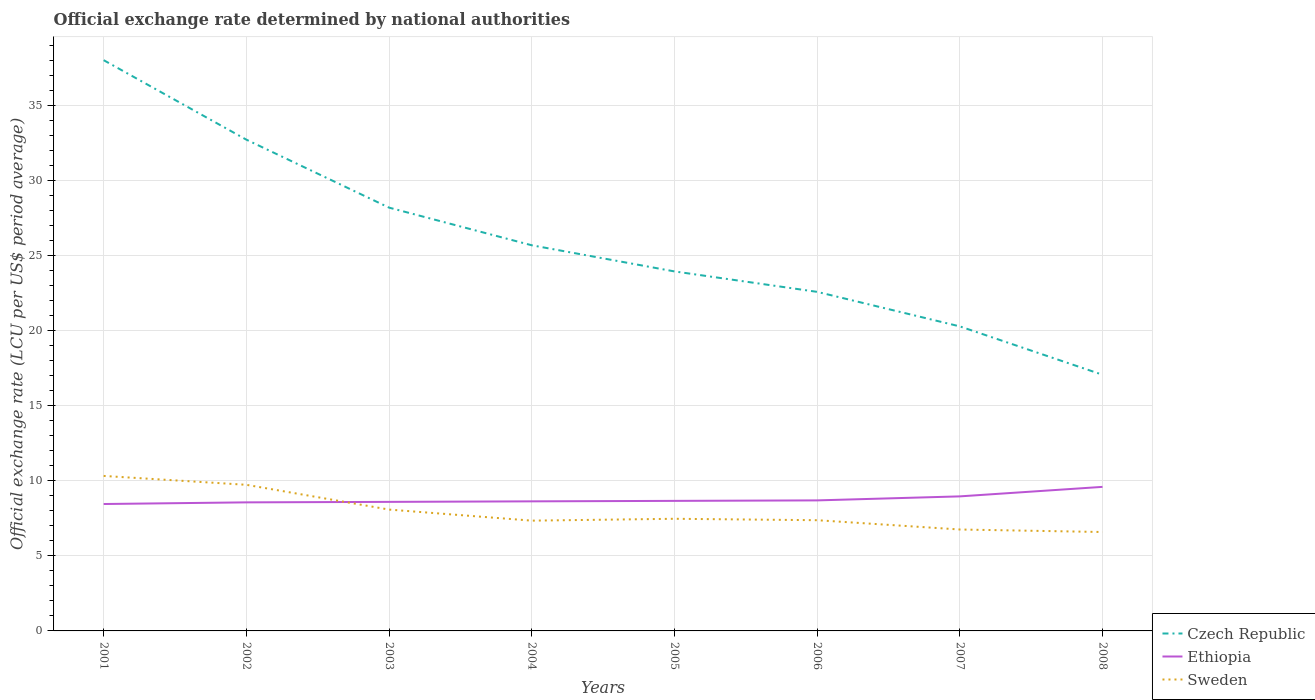Does the line corresponding to Czech Republic intersect with the line corresponding to Ethiopia?
Keep it short and to the point. No. Across all years, what is the maximum official exchange rate in Sweden?
Give a very brief answer. 6.59. What is the total official exchange rate in Sweden in the graph?
Keep it short and to the point. 0.17. What is the difference between the highest and the second highest official exchange rate in Sweden?
Offer a terse response. 3.74. What is the difference between the highest and the lowest official exchange rate in Ethiopia?
Offer a very short reply. 2. How many lines are there?
Provide a short and direct response. 3. How many years are there in the graph?
Offer a terse response. 8. Does the graph contain grids?
Ensure brevity in your answer.  Yes. What is the title of the graph?
Offer a terse response. Official exchange rate determined by national authorities. Does "Bahamas" appear as one of the legend labels in the graph?
Ensure brevity in your answer.  No. What is the label or title of the Y-axis?
Offer a very short reply. Official exchange rate (LCU per US$ period average). What is the Official exchange rate (LCU per US$ period average) of Czech Republic in 2001?
Ensure brevity in your answer.  38.04. What is the Official exchange rate (LCU per US$ period average) of Ethiopia in 2001?
Provide a short and direct response. 8.46. What is the Official exchange rate (LCU per US$ period average) in Sweden in 2001?
Offer a terse response. 10.33. What is the Official exchange rate (LCU per US$ period average) in Czech Republic in 2002?
Ensure brevity in your answer.  32.74. What is the Official exchange rate (LCU per US$ period average) of Ethiopia in 2002?
Offer a terse response. 8.57. What is the Official exchange rate (LCU per US$ period average) in Sweden in 2002?
Your answer should be very brief. 9.74. What is the Official exchange rate (LCU per US$ period average) in Czech Republic in 2003?
Your answer should be compact. 28.21. What is the Official exchange rate (LCU per US$ period average) of Ethiopia in 2003?
Make the answer very short. 8.6. What is the Official exchange rate (LCU per US$ period average) in Sweden in 2003?
Provide a short and direct response. 8.09. What is the Official exchange rate (LCU per US$ period average) in Czech Republic in 2004?
Keep it short and to the point. 25.7. What is the Official exchange rate (LCU per US$ period average) in Ethiopia in 2004?
Make the answer very short. 8.64. What is the Official exchange rate (LCU per US$ period average) in Sweden in 2004?
Provide a succinct answer. 7.35. What is the Official exchange rate (LCU per US$ period average) of Czech Republic in 2005?
Your answer should be very brief. 23.96. What is the Official exchange rate (LCU per US$ period average) of Ethiopia in 2005?
Ensure brevity in your answer.  8.67. What is the Official exchange rate (LCU per US$ period average) in Sweden in 2005?
Give a very brief answer. 7.47. What is the Official exchange rate (LCU per US$ period average) of Czech Republic in 2006?
Your response must be concise. 22.6. What is the Official exchange rate (LCU per US$ period average) in Ethiopia in 2006?
Provide a short and direct response. 8.7. What is the Official exchange rate (LCU per US$ period average) in Sweden in 2006?
Make the answer very short. 7.38. What is the Official exchange rate (LCU per US$ period average) of Czech Republic in 2007?
Your response must be concise. 20.29. What is the Official exchange rate (LCU per US$ period average) of Ethiopia in 2007?
Offer a very short reply. 8.97. What is the Official exchange rate (LCU per US$ period average) in Sweden in 2007?
Your response must be concise. 6.76. What is the Official exchange rate (LCU per US$ period average) in Czech Republic in 2008?
Your answer should be very brief. 17.07. What is the Official exchange rate (LCU per US$ period average) of Ethiopia in 2008?
Your response must be concise. 9.6. What is the Official exchange rate (LCU per US$ period average) in Sweden in 2008?
Offer a very short reply. 6.59. Across all years, what is the maximum Official exchange rate (LCU per US$ period average) in Czech Republic?
Provide a short and direct response. 38.04. Across all years, what is the maximum Official exchange rate (LCU per US$ period average) of Ethiopia?
Offer a very short reply. 9.6. Across all years, what is the maximum Official exchange rate (LCU per US$ period average) in Sweden?
Offer a very short reply. 10.33. Across all years, what is the minimum Official exchange rate (LCU per US$ period average) of Czech Republic?
Give a very brief answer. 17.07. Across all years, what is the minimum Official exchange rate (LCU per US$ period average) of Ethiopia?
Provide a short and direct response. 8.46. Across all years, what is the minimum Official exchange rate (LCU per US$ period average) of Sweden?
Keep it short and to the point. 6.59. What is the total Official exchange rate (LCU per US$ period average) in Czech Republic in the graph?
Your answer should be compact. 208.6. What is the total Official exchange rate (LCU per US$ period average) of Ethiopia in the graph?
Keep it short and to the point. 70.19. What is the total Official exchange rate (LCU per US$ period average) of Sweden in the graph?
Offer a very short reply. 63.7. What is the difference between the Official exchange rate (LCU per US$ period average) of Czech Republic in 2001 and that in 2002?
Your response must be concise. 5.3. What is the difference between the Official exchange rate (LCU per US$ period average) in Ethiopia in 2001 and that in 2002?
Keep it short and to the point. -0.11. What is the difference between the Official exchange rate (LCU per US$ period average) in Sweden in 2001 and that in 2002?
Offer a very short reply. 0.59. What is the difference between the Official exchange rate (LCU per US$ period average) in Czech Republic in 2001 and that in 2003?
Give a very brief answer. 9.83. What is the difference between the Official exchange rate (LCU per US$ period average) of Ethiopia in 2001 and that in 2003?
Give a very brief answer. -0.14. What is the difference between the Official exchange rate (LCU per US$ period average) in Sweden in 2001 and that in 2003?
Ensure brevity in your answer.  2.24. What is the difference between the Official exchange rate (LCU per US$ period average) of Czech Republic in 2001 and that in 2004?
Your answer should be compact. 12.34. What is the difference between the Official exchange rate (LCU per US$ period average) of Ethiopia in 2001 and that in 2004?
Offer a terse response. -0.18. What is the difference between the Official exchange rate (LCU per US$ period average) of Sweden in 2001 and that in 2004?
Offer a terse response. 2.98. What is the difference between the Official exchange rate (LCU per US$ period average) of Czech Republic in 2001 and that in 2005?
Your answer should be compact. 14.08. What is the difference between the Official exchange rate (LCU per US$ period average) of Ethiopia in 2001 and that in 2005?
Give a very brief answer. -0.21. What is the difference between the Official exchange rate (LCU per US$ period average) in Sweden in 2001 and that in 2005?
Offer a terse response. 2.86. What is the difference between the Official exchange rate (LCU per US$ period average) of Czech Republic in 2001 and that in 2006?
Offer a very short reply. 15.44. What is the difference between the Official exchange rate (LCU per US$ period average) in Ethiopia in 2001 and that in 2006?
Offer a terse response. -0.24. What is the difference between the Official exchange rate (LCU per US$ period average) of Sweden in 2001 and that in 2006?
Provide a short and direct response. 2.95. What is the difference between the Official exchange rate (LCU per US$ period average) of Czech Republic in 2001 and that in 2007?
Provide a short and direct response. 17.74. What is the difference between the Official exchange rate (LCU per US$ period average) of Ethiopia in 2001 and that in 2007?
Offer a terse response. -0.51. What is the difference between the Official exchange rate (LCU per US$ period average) of Sweden in 2001 and that in 2007?
Provide a succinct answer. 3.57. What is the difference between the Official exchange rate (LCU per US$ period average) of Czech Republic in 2001 and that in 2008?
Offer a very short reply. 20.96. What is the difference between the Official exchange rate (LCU per US$ period average) of Ethiopia in 2001 and that in 2008?
Offer a terse response. -1.14. What is the difference between the Official exchange rate (LCU per US$ period average) in Sweden in 2001 and that in 2008?
Provide a short and direct response. 3.74. What is the difference between the Official exchange rate (LCU per US$ period average) of Czech Republic in 2002 and that in 2003?
Your answer should be compact. 4.53. What is the difference between the Official exchange rate (LCU per US$ period average) of Ethiopia in 2002 and that in 2003?
Offer a terse response. -0.03. What is the difference between the Official exchange rate (LCU per US$ period average) in Sweden in 2002 and that in 2003?
Your answer should be very brief. 1.65. What is the difference between the Official exchange rate (LCU per US$ period average) of Czech Republic in 2002 and that in 2004?
Offer a very short reply. 7.04. What is the difference between the Official exchange rate (LCU per US$ period average) in Ethiopia in 2002 and that in 2004?
Offer a very short reply. -0.07. What is the difference between the Official exchange rate (LCU per US$ period average) of Sweden in 2002 and that in 2004?
Offer a very short reply. 2.39. What is the difference between the Official exchange rate (LCU per US$ period average) of Czech Republic in 2002 and that in 2005?
Your response must be concise. 8.78. What is the difference between the Official exchange rate (LCU per US$ period average) in Ethiopia in 2002 and that in 2005?
Your response must be concise. -0.1. What is the difference between the Official exchange rate (LCU per US$ period average) of Sweden in 2002 and that in 2005?
Keep it short and to the point. 2.26. What is the difference between the Official exchange rate (LCU per US$ period average) of Czech Republic in 2002 and that in 2006?
Give a very brief answer. 10.14. What is the difference between the Official exchange rate (LCU per US$ period average) in Ethiopia in 2002 and that in 2006?
Offer a terse response. -0.13. What is the difference between the Official exchange rate (LCU per US$ period average) in Sweden in 2002 and that in 2006?
Your answer should be very brief. 2.36. What is the difference between the Official exchange rate (LCU per US$ period average) of Czech Republic in 2002 and that in 2007?
Ensure brevity in your answer.  12.44. What is the difference between the Official exchange rate (LCU per US$ period average) of Ethiopia in 2002 and that in 2007?
Your answer should be very brief. -0.4. What is the difference between the Official exchange rate (LCU per US$ period average) in Sweden in 2002 and that in 2007?
Offer a terse response. 2.98. What is the difference between the Official exchange rate (LCU per US$ period average) of Czech Republic in 2002 and that in 2008?
Your response must be concise. 15.67. What is the difference between the Official exchange rate (LCU per US$ period average) in Ethiopia in 2002 and that in 2008?
Provide a short and direct response. -1.03. What is the difference between the Official exchange rate (LCU per US$ period average) in Sweden in 2002 and that in 2008?
Ensure brevity in your answer.  3.15. What is the difference between the Official exchange rate (LCU per US$ period average) of Czech Republic in 2003 and that in 2004?
Keep it short and to the point. 2.51. What is the difference between the Official exchange rate (LCU per US$ period average) in Ethiopia in 2003 and that in 2004?
Make the answer very short. -0.04. What is the difference between the Official exchange rate (LCU per US$ period average) of Sweden in 2003 and that in 2004?
Your answer should be very brief. 0.74. What is the difference between the Official exchange rate (LCU per US$ period average) of Czech Republic in 2003 and that in 2005?
Provide a short and direct response. 4.25. What is the difference between the Official exchange rate (LCU per US$ period average) in Ethiopia in 2003 and that in 2005?
Provide a succinct answer. -0.07. What is the difference between the Official exchange rate (LCU per US$ period average) of Sweden in 2003 and that in 2005?
Offer a very short reply. 0.61. What is the difference between the Official exchange rate (LCU per US$ period average) of Czech Republic in 2003 and that in 2006?
Provide a short and direct response. 5.61. What is the difference between the Official exchange rate (LCU per US$ period average) in Ethiopia in 2003 and that in 2006?
Your response must be concise. -0.1. What is the difference between the Official exchange rate (LCU per US$ period average) in Sweden in 2003 and that in 2006?
Your answer should be compact. 0.71. What is the difference between the Official exchange rate (LCU per US$ period average) in Czech Republic in 2003 and that in 2007?
Make the answer very short. 7.92. What is the difference between the Official exchange rate (LCU per US$ period average) in Ethiopia in 2003 and that in 2007?
Your answer should be compact. -0.37. What is the difference between the Official exchange rate (LCU per US$ period average) in Sweden in 2003 and that in 2007?
Provide a short and direct response. 1.33. What is the difference between the Official exchange rate (LCU per US$ period average) of Czech Republic in 2003 and that in 2008?
Offer a terse response. 11.14. What is the difference between the Official exchange rate (LCU per US$ period average) of Ethiopia in 2003 and that in 2008?
Keep it short and to the point. -1. What is the difference between the Official exchange rate (LCU per US$ period average) of Sweden in 2003 and that in 2008?
Offer a terse response. 1.5. What is the difference between the Official exchange rate (LCU per US$ period average) in Czech Republic in 2004 and that in 2005?
Provide a short and direct response. 1.74. What is the difference between the Official exchange rate (LCU per US$ period average) of Ethiopia in 2004 and that in 2005?
Offer a very short reply. -0.03. What is the difference between the Official exchange rate (LCU per US$ period average) in Sweden in 2004 and that in 2005?
Offer a very short reply. -0.12. What is the difference between the Official exchange rate (LCU per US$ period average) of Czech Republic in 2004 and that in 2006?
Ensure brevity in your answer.  3.1. What is the difference between the Official exchange rate (LCU per US$ period average) of Ethiopia in 2004 and that in 2006?
Provide a succinct answer. -0.06. What is the difference between the Official exchange rate (LCU per US$ period average) in Sweden in 2004 and that in 2006?
Your answer should be very brief. -0.03. What is the difference between the Official exchange rate (LCU per US$ period average) in Czech Republic in 2004 and that in 2007?
Offer a terse response. 5.41. What is the difference between the Official exchange rate (LCU per US$ period average) of Ethiopia in 2004 and that in 2007?
Your answer should be compact. -0.33. What is the difference between the Official exchange rate (LCU per US$ period average) in Sweden in 2004 and that in 2007?
Ensure brevity in your answer.  0.59. What is the difference between the Official exchange rate (LCU per US$ period average) in Czech Republic in 2004 and that in 2008?
Your answer should be very brief. 8.63. What is the difference between the Official exchange rate (LCU per US$ period average) in Ethiopia in 2004 and that in 2008?
Your answer should be very brief. -0.96. What is the difference between the Official exchange rate (LCU per US$ period average) in Sweden in 2004 and that in 2008?
Provide a succinct answer. 0.76. What is the difference between the Official exchange rate (LCU per US$ period average) in Czech Republic in 2005 and that in 2006?
Your answer should be very brief. 1.36. What is the difference between the Official exchange rate (LCU per US$ period average) in Ethiopia in 2005 and that in 2006?
Your answer should be compact. -0.03. What is the difference between the Official exchange rate (LCU per US$ period average) in Sweden in 2005 and that in 2006?
Your answer should be compact. 0.09. What is the difference between the Official exchange rate (LCU per US$ period average) of Czech Republic in 2005 and that in 2007?
Give a very brief answer. 3.66. What is the difference between the Official exchange rate (LCU per US$ period average) of Ethiopia in 2005 and that in 2007?
Offer a very short reply. -0.3. What is the difference between the Official exchange rate (LCU per US$ period average) of Sweden in 2005 and that in 2007?
Keep it short and to the point. 0.71. What is the difference between the Official exchange rate (LCU per US$ period average) of Czech Republic in 2005 and that in 2008?
Offer a terse response. 6.89. What is the difference between the Official exchange rate (LCU per US$ period average) in Ethiopia in 2005 and that in 2008?
Offer a very short reply. -0.93. What is the difference between the Official exchange rate (LCU per US$ period average) in Sweden in 2005 and that in 2008?
Offer a very short reply. 0.88. What is the difference between the Official exchange rate (LCU per US$ period average) of Czech Republic in 2006 and that in 2007?
Offer a terse response. 2.3. What is the difference between the Official exchange rate (LCU per US$ period average) of Ethiopia in 2006 and that in 2007?
Your response must be concise. -0.27. What is the difference between the Official exchange rate (LCU per US$ period average) in Sweden in 2006 and that in 2007?
Give a very brief answer. 0.62. What is the difference between the Official exchange rate (LCU per US$ period average) of Czech Republic in 2006 and that in 2008?
Provide a short and direct response. 5.52. What is the difference between the Official exchange rate (LCU per US$ period average) in Ethiopia in 2006 and that in 2008?
Offer a terse response. -0.9. What is the difference between the Official exchange rate (LCU per US$ period average) of Sweden in 2006 and that in 2008?
Ensure brevity in your answer.  0.79. What is the difference between the Official exchange rate (LCU per US$ period average) of Czech Republic in 2007 and that in 2008?
Provide a succinct answer. 3.22. What is the difference between the Official exchange rate (LCU per US$ period average) of Ethiopia in 2007 and that in 2008?
Your answer should be compact. -0.63. What is the difference between the Official exchange rate (LCU per US$ period average) in Sweden in 2007 and that in 2008?
Provide a short and direct response. 0.17. What is the difference between the Official exchange rate (LCU per US$ period average) of Czech Republic in 2001 and the Official exchange rate (LCU per US$ period average) of Ethiopia in 2002?
Offer a very short reply. 29.47. What is the difference between the Official exchange rate (LCU per US$ period average) of Czech Republic in 2001 and the Official exchange rate (LCU per US$ period average) of Sweden in 2002?
Provide a succinct answer. 28.3. What is the difference between the Official exchange rate (LCU per US$ period average) of Ethiopia in 2001 and the Official exchange rate (LCU per US$ period average) of Sweden in 2002?
Keep it short and to the point. -1.28. What is the difference between the Official exchange rate (LCU per US$ period average) of Czech Republic in 2001 and the Official exchange rate (LCU per US$ period average) of Ethiopia in 2003?
Offer a terse response. 29.44. What is the difference between the Official exchange rate (LCU per US$ period average) of Czech Republic in 2001 and the Official exchange rate (LCU per US$ period average) of Sweden in 2003?
Give a very brief answer. 29.95. What is the difference between the Official exchange rate (LCU per US$ period average) of Ethiopia in 2001 and the Official exchange rate (LCU per US$ period average) of Sweden in 2003?
Your answer should be very brief. 0.37. What is the difference between the Official exchange rate (LCU per US$ period average) of Czech Republic in 2001 and the Official exchange rate (LCU per US$ period average) of Ethiopia in 2004?
Give a very brief answer. 29.4. What is the difference between the Official exchange rate (LCU per US$ period average) of Czech Republic in 2001 and the Official exchange rate (LCU per US$ period average) of Sweden in 2004?
Make the answer very short. 30.69. What is the difference between the Official exchange rate (LCU per US$ period average) in Ethiopia in 2001 and the Official exchange rate (LCU per US$ period average) in Sweden in 2004?
Provide a succinct answer. 1.11. What is the difference between the Official exchange rate (LCU per US$ period average) in Czech Republic in 2001 and the Official exchange rate (LCU per US$ period average) in Ethiopia in 2005?
Give a very brief answer. 29.37. What is the difference between the Official exchange rate (LCU per US$ period average) in Czech Republic in 2001 and the Official exchange rate (LCU per US$ period average) in Sweden in 2005?
Make the answer very short. 30.56. What is the difference between the Official exchange rate (LCU per US$ period average) of Ethiopia in 2001 and the Official exchange rate (LCU per US$ period average) of Sweden in 2005?
Your answer should be compact. 0.98. What is the difference between the Official exchange rate (LCU per US$ period average) of Czech Republic in 2001 and the Official exchange rate (LCU per US$ period average) of Ethiopia in 2006?
Provide a succinct answer. 29.34. What is the difference between the Official exchange rate (LCU per US$ period average) of Czech Republic in 2001 and the Official exchange rate (LCU per US$ period average) of Sweden in 2006?
Make the answer very short. 30.66. What is the difference between the Official exchange rate (LCU per US$ period average) of Ethiopia in 2001 and the Official exchange rate (LCU per US$ period average) of Sweden in 2006?
Ensure brevity in your answer.  1.08. What is the difference between the Official exchange rate (LCU per US$ period average) of Czech Republic in 2001 and the Official exchange rate (LCU per US$ period average) of Ethiopia in 2007?
Provide a succinct answer. 29.07. What is the difference between the Official exchange rate (LCU per US$ period average) of Czech Republic in 2001 and the Official exchange rate (LCU per US$ period average) of Sweden in 2007?
Give a very brief answer. 31.28. What is the difference between the Official exchange rate (LCU per US$ period average) in Ethiopia in 2001 and the Official exchange rate (LCU per US$ period average) in Sweden in 2007?
Offer a very short reply. 1.7. What is the difference between the Official exchange rate (LCU per US$ period average) in Czech Republic in 2001 and the Official exchange rate (LCU per US$ period average) in Ethiopia in 2008?
Give a very brief answer. 28.44. What is the difference between the Official exchange rate (LCU per US$ period average) in Czech Republic in 2001 and the Official exchange rate (LCU per US$ period average) in Sweden in 2008?
Keep it short and to the point. 31.44. What is the difference between the Official exchange rate (LCU per US$ period average) in Ethiopia in 2001 and the Official exchange rate (LCU per US$ period average) in Sweden in 2008?
Your answer should be compact. 1.87. What is the difference between the Official exchange rate (LCU per US$ period average) of Czech Republic in 2002 and the Official exchange rate (LCU per US$ period average) of Ethiopia in 2003?
Provide a succinct answer. 24.14. What is the difference between the Official exchange rate (LCU per US$ period average) in Czech Republic in 2002 and the Official exchange rate (LCU per US$ period average) in Sweden in 2003?
Offer a terse response. 24.65. What is the difference between the Official exchange rate (LCU per US$ period average) in Ethiopia in 2002 and the Official exchange rate (LCU per US$ period average) in Sweden in 2003?
Your answer should be compact. 0.48. What is the difference between the Official exchange rate (LCU per US$ period average) of Czech Republic in 2002 and the Official exchange rate (LCU per US$ period average) of Ethiopia in 2004?
Keep it short and to the point. 24.1. What is the difference between the Official exchange rate (LCU per US$ period average) of Czech Republic in 2002 and the Official exchange rate (LCU per US$ period average) of Sweden in 2004?
Your answer should be compact. 25.39. What is the difference between the Official exchange rate (LCU per US$ period average) of Ethiopia in 2002 and the Official exchange rate (LCU per US$ period average) of Sweden in 2004?
Give a very brief answer. 1.22. What is the difference between the Official exchange rate (LCU per US$ period average) of Czech Republic in 2002 and the Official exchange rate (LCU per US$ period average) of Ethiopia in 2005?
Offer a very short reply. 24.07. What is the difference between the Official exchange rate (LCU per US$ period average) in Czech Republic in 2002 and the Official exchange rate (LCU per US$ period average) in Sweden in 2005?
Offer a terse response. 25.27. What is the difference between the Official exchange rate (LCU per US$ period average) in Ethiopia in 2002 and the Official exchange rate (LCU per US$ period average) in Sweden in 2005?
Make the answer very short. 1.09. What is the difference between the Official exchange rate (LCU per US$ period average) of Czech Republic in 2002 and the Official exchange rate (LCU per US$ period average) of Ethiopia in 2006?
Keep it short and to the point. 24.04. What is the difference between the Official exchange rate (LCU per US$ period average) of Czech Republic in 2002 and the Official exchange rate (LCU per US$ period average) of Sweden in 2006?
Offer a very short reply. 25.36. What is the difference between the Official exchange rate (LCU per US$ period average) in Ethiopia in 2002 and the Official exchange rate (LCU per US$ period average) in Sweden in 2006?
Offer a terse response. 1.19. What is the difference between the Official exchange rate (LCU per US$ period average) in Czech Republic in 2002 and the Official exchange rate (LCU per US$ period average) in Ethiopia in 2007?
Make the answer very short. 23.77. What is the difference between the Official exchange rate (LCU per US$ period average) of Czech Republic in 2002 and the Official exchange rate (LCU per US$ period average) of Sweden in 2007?
Your answer should be compact. 25.98. What is the difference between the Official exchange rate (LCU per US$ period average) in Ethiopia in 2002 and the Official exchange rate (LCU per US$ period average) in Sweden in 2007?
Your response must be concise. 1.81. What is the difference between the Official exchange rate (LCU per US$ period average) in Czech Republic in 2002 and the Official exchange rate (LCU per US$ period average) in Ethiopia in 2008?
Provide a succinct answer. 23.14. What is the difference between the Official exchange rate (LCU per US$ period average) of Czech Republic in 2002 and the Official exchange rate (LCU per US$ period average) of Sweden in 2008?
Offer a terse response. 26.15. What is the difference between the Official exchange rate (LCU per US$ period average) of Ethiopia in 2002 and the Official exchange rate (LCU per US$ period average) of Sweden in 2008?
Your answer should be compact. 1.98. What is the difference between the Official exchange rate (LCU per US$ period average) of Czech Republic in 2003 and the Official exchange rate (LCU per US$ period average) of Ethiopia in 2004?
Make the answer very short. 19.57. What is the difference between the Official exchange rate (LCU per US$ period average) in Czech Republic in 2003 and the Official exchange rate (LCU per US$ period average) in Sweden in 2004?
Keep it short and to the point. 20.86. What is the difference between the Official exchange rate (LCU per US$ period average) of Ethiopia in 2003 and the Official exchange rate (LCU per US$ period average) of Sweden in 2004?
Offer a very short reply. 1.25. What is the difference between the Official exchange rate (LCU per US$ period average) in Czech Republic in 2003 and the Official exchange rate (LCU per US$ period average) in Ethiopia in 2005?
Your response must be concise. 19.54. What is the difference between the Official exchange rate (LCU per US$ period average) in Czech Republic in 2003 and the Official exchange rate (LCU per US$ period average) in Sweden in 2005?
Provide a succinct answer. 20.74. What is the difference between the Official exchange rate (LCU per US$ period average) of Ethiopia in 2003 and the Official exchange rate (LCU per US$ period average) of Sweden in 2005?
Offer a terse response. 1.13. What is the difference between the Official exchange rate (LCU per US$ period average) in Czech Republic in 2003 and the Official exchange rate (LCU per US$ period average) in Ethiopia in 2006?
Give a very brief answer. 19.51. What is the difference between the Official exchange rate (LCU per US$ period average) of Czech Republic in 2003 and the Official exchange rate (LCU per US$ period average) of Sweden in 2006?
Offer a very short reply. 20.83. What is the difference between the Official exchange rate (LCU per US$ period average) of Ethiopia in 2003 and the Official exchange rate (LCU per US$ period average) of Sweden in 2006?
Keep it short and to the point. 1.22. What is the difference between the Official exchange rate (LCU per US$ period average) of Czech Republic in 2003 and the Official exchange rate (LCU per US$ period average) of Ethiopia in 2007?
Provide a succinct answer. 19.24. What is the difference between the Official exchange rate (LCU per US$ period average) of Czech Republic in 2003 and the Official exchange rate (LCU per US$ period average) of Sweden in 2007?
Provide a short and direct response. 21.45. What is the difference between the Official exchange rate (LCU per US$ period average) in Ethiopia in 2003 and the Official exchange rate (LCU per US$ period average) in Sweden in 2007?
Keep it short and to the point. 1.84. What is the difference between the Official exchange rate (LCU per US$ period average) in Czech Republic in 2003 and the Official exchange rate (LCU per US$ period average) in Ethiopia in 2008?
Your response must be concise. 18.61. What is the difference between the Official exchange rate (LCU per US$ period average) in Czech Republic in 2003 and the Official exchange rate (LCU per US$ period average) in Sweden in 2008?
Keep it short and to the point. 21.62. What is the difference between the Official exchange rate (LCU per US$ period average) of Ethiopia in 2003 and the Official exchange rate (LCU per US$ period average) of Sweden in 2008?
Your response must be concise. 2.01. What is the difference between the Official exchange rate (LCU per US$ period average) of Czech Republic in 2004 and the Official exchange rate (LCU per US$ period average) of Ethiopia in 2005?
Your answer should be compact. 17.03. What is the difference between the Official exchange rate (LCU per US$ period average) of Czech Republic in 2004 and the Official exchange rate (LCU per US$ period average) of Sweden in 2005?
Make the answer very short. 18.23. What is the difference between the Official exchange rate (LCU per US$ period average) of Ethiopia in 2004 and the Official exchange rate (LCU per US$ period average) of Sweden in 2005?
Your answer should be very brief. 1.16. What is the difference between the Official exchange rate (LCU per US$ period average) in Czech Republic in 2004 and the Official exchange rate (LCU per US$ period average) in Ethiopia in 2006?
Your response must be concise. 17. What is the difference between the Official exchange rate (LCU per US$ period average) in Czech Republic in 2004 and the Official exchange rate (LCU per US$ period average) in Sweden in 2006?
Your answer should be very brief. 18.32. What is the difference between the Official exchange rate (LCU per US$ period average) of Ethiopia in 2004 and the Official exchange rate (LCU per US$ period average) of Sweden in 2006?
Offer a terse response. 1.26. What is the difference between the Official exchange rate (LCU per US$ period average) of Czech Republic in 2004 and the Official exchange rate (LCU per US$ period average) of Ethiopia in 2007?
Your response must be concise. 16.73. What is the difference between the Official exchange rate (LCU per US$ period average) of Czech Republic in 2004 and the Official exchange rate (LCU per US$ period average) of Sweden in 2007?
Offer a very short reply. 18.94. What is the difference between the Official exchange rate (LCU per US$ period average) of Ethiopia in 2004 and the Official exchange rate (LCU per US$ period average) of Sweden in 2007?
Your response must be concise. 1.88. What is the difference between the Official exchange rate (LCU per US$ period average) of Czech Republic in 2004 and the Official exchange rate (LCU per US$ period average) of Ethiopia in 2008?
Your answer should be very brief. 16.1. What is the difference between the Official exchange rate (LCU per US$ period average) in Czech Republic in 2004 and the Official exchange rate (LCU per US$ period average) in Sweden in 2008?
Your response must be concise. 19.11. What is the difference between the Official exchange rate (LCU per US$ period average) in Ethiopia in 2004 and the Official exchange rate (LCU per US$ period average) in Sweden in 2008?
Keep it short and to the point. 2.04. What is the difference between the Official exchange rate (LCU per US$ period average) of Czech Republic in 2005 and the Official exchange rate (LCU per US$ period average) of Ethiopia in 2006?
Make the answer very short. 15.26. What is the difference between the Official exchange rate (LCU per US$ period average) in Czech Republic in 2005 and the Official exchange rate (LCU per US$ period average) in Sweden in 2006?
Your response must be concise. 16.58. What is the difference between the Official exchange rate (LCU per US$ period average) of Ethiopia in 2005 and the Official exchange rate (LCU per US$ period average) of Sweden in 2006?
Provide a short and direct response. 1.29. What is the difference between the Official exchange rate (LCU per US$ period average) of Czech Republic in 2005 and the Official exchange rate (LCU per US$ period average) of Ethiopia in 2007?
Your response must be concise. 14.99. What is the difference between the Official exchange rate (LCU per US$ period average) of Czech Republic in 2005 and the Official exchange rate (LCU per US$ period average) of Sweden in 2007?
Offer a very short reply. 17.2. What is the difference between the Official exchange rate (LCU per US$ period average) in Ethiopia in 2005 and the Official exchange rate (LCU per US$ period average) in Sweden in 2007?
Your response must be concise. 1.91. What is the difference between the Official exchange rate (LCU per US$ period average) of Czech Republic in 2005 and the Official exchange rate (LCU per US$ period average) of Ethiopia in 2008?
Give a very brief answer. 14.36. What is the difference between the Official exchange rate (LCU per US$ period average) in Czech Republic in 2005 and the Official exchange rate (LCU per US$ period average) in Sweden in 2008?
Your response must be concise. 17.37. What is the difference between the Official exchange rate (LCU per US$ period average) in Ethiopia in 2005 and the Official exchange rate (LCU per US$ period average) in Sweden in 2008?
Ensure brevity in your answer.  2.08. What is the difference between the Official exchange rate (LCU per US$ period average) in Czech Republic in 2006 and the Official exchange rate (LCU per US$ period average) in Ethiopia in 2007?
Provide a short and direct response. 13.63. What is the difference between the Official exchange rate (LCU per US$ period average) in Czech Republic in 2006 and the Official exchange rate (LCU per US$ period average) in Sweden in 2007?
Give a very brief answer. 15.84. What is the difference between the Official exchange rate (LCU per US$ period average) in Ethiopia in 2006 and the Official exchange rate (LCU per US$ period average) in Sweden in 2007?
Keep it short and to the point. 1.94. What is the difference between the Official exchange rate (LCU per US$ period average) in Czech Republic in 2006 and the Official exchange rate (LCU per US$ period average) in Ethiopia in 2008?
Offer a very short reply. 13. What is the difference between the Official exchange rate (LCU per US$ period average) in Czech Republic in 2006 and the Official exchange rate (LCU per US$ period average) in Sweden in 2008?
Your answer should be very brief. 16. What is the difference between the Official exchange rate (LCU per US$ period average) in Ethiopia in 2006 and the Official exchange rate (LCU per US$ period average) in Sweden in 2008?
Offer a terse response. 2.11. What is the difference between the Official exchange rate (LCU per US$ period average) of Czech Republic in 2007 and the Official exchange rate (LCU per US$ period average) of Ethiopia in 2008?
Ensure brevity in your answer.  10.69. What is the difference between the Official exchange rate (LCU per US$ period average) in Czech Republic in 2007 and the Official exchange rate (LCU per US$ period average) in Sweden in 2008?
Offer a terse response. 13.7. What is the difference between the Official exchange rate (LCU per US$ period average) in Ethiopia in 2007 and the Official exchange rate (LCU per US$ period average) in Sweden in 2008?
Provide a succinct answer. 2.37. What is the average Official exchange rate (LCU per US$ period average) in Czech Republic per year?
Your response must be concise. 26.08. What is the average Official exchange rate (LCU per US$ period average) of Ethiopia per year?
Provide a short and direct response. 8.77. What is the average Official exchange rate (LCU per US$ period average) of Sweden per year?
Offer a terse response. 7.96. In the year 2001, what is the difference between the Official exchange rate (LCU per US$ period average) of Czech Republic and Official exchange rate (LCU per US$ period average) of Ethiopia?
Offer a very short reply. 29.58. In the year 2001, what is the difference between the Official exchange rate (LCU per US$ period average) of Czech Republic and Official exchange rate (LCU per US$ period average) of Sweden?
Offer a terse response. 27.71. In the year 2001, what is the difference between the Official exchange rate (LCU per US$ period average) in Ethiopia and Official exchange rate (LCU per US$ period average) in Sweden?
Offer a very short reply. -1.87. In the year 2002, what is the difference between the Official exchange rate (LCU per US$ period average) of Czech Republic and Official exchange rate (LCU per US$ period average) of Ethiopia?
Give a very brief answer. 24.17. In the year 2002, what is the difference between the Official exchange rate (LCU per US$ period average) of Czech Republic and Official exchange rate (LCU per US$ period average) of Sweden?
Ensure brevity in your answer.  23. In the year 2002, what is the difference between the Official exchange rate (LCU per US$ period average) in Ethiopia and Official exchange rate (LCU per US$ period average) in Sweden?
Give a very brief answer. -1.17. In the year 2003, what is the difference between the Official exchange rate (LCU per US$ period average) of Czech Republic and Official exchange rate (LCU per US$ period average) of Ethiopia?
Keep it short and to the point. 19.61. In the year 2003, what is the difference between the Official exchange rate (LCU per US$ period average) of Czech Republic and Official exchange rate (LCU per US$ period average) of Sweden?
Your response must be concise. 20.12. In the year 2003, what is the difference between the Official exchange rate (LCU per US$ period average) in Ethiopia and Official exchange rate (LCU per US$ period average) in Sweden?
Give a very brief answer. 0.51. In the year 2004, what is the difference between the Official exchange rate (LCU per US$ period average) in Czech Republic and Official exchange rate (LCU per US$ period average) in Ethiopia?
Your answer should be very brief. 17.06. In the year 2004, what is the difference between the Official exchange rate (LCU per US$ period average) of Czech Republic and Official exchange rate (LCU per US$ period average) of Sweden?
Ensure brevity in your answer.  18.35. In the year 2004, what is the difference between the Official exchange rate (LCU per US$ period average) in Ethiopia and Official exchange rate (LCU per US$ period average) in Sweden?
Give a very brief answer. 1.29. In the year 2005, what is the difference between the Official exchange rate (LCU per US$ period average) in Czech Republic and Official exchange rate (LCU per US$ period average) in Ethiopia?
Your answer should be very brief. 15.29. In the year 2005, what is the difference between the Official exchange rate (LCU per US$ period average) in Czech Republic and Official exchange rate (LCU per US$ period average) in Sweden?
Your response must be concise. 16.48. In the year 2005, what is the difference between the Official exchange rate (LCU per US$ period average) of Ethiopia and Official exchange rate (LCU per US$ period average) of Sweden?
Your answer should be very brief. 1.19. In the year 2006, what is the difference between the Official exchange rate (LCU per US$ period average) in Czech Republic and Official exchange rate (LCU per US$ period average) in Ethiopia?
Offer a terse response. 13.9. In the year 2006, what is the difference between the Official exchange rate (LCU per US$ period average) in Czech Republic and Official exchange rate (LCU per US$ period average) in Sweden?
Provide a succinct answer. 15.22. In the year 2006, what is the difference between the Official exchange rate (LCU per US$ period average) in Ethiopia and Official exchange rate (LCU per US$ period average) in Sweden?
Make the answer very short. 1.32. In the year 2007, what is the difference between the Official exchange rate (LCU per US$ period average) in Czech Republic and Official exchange rate (LCU per US$ period average) in Ethiopia?
Your answer should be compact. 11.33. In the year 2007, what is the difference between the Official exchange rate (LCU per US$ period average) in Czech Republic and Official exchange rate (LCU per US$ period average) in Sweden?
Offer a terse response. 13.53. In the year 2007, what is the difference between the Official exchange rate (LCU per US$ period average) of Ethiopia and Official exchange rate (LCU per US$ period average) of Sweden?
Provide a succinct answer. 2.21. In the year 2008, what is the difference between the Official exchange rate (LCU per US$ period average) in Czech Republic and Official exchange rate (LCU per US$ period average) in Ethiopia?
Offer a very short reply. 7.47. In the year 2008, what is the difference between the Official exchange rate (LCU per US$ period average) of Czech Republic and Official exchange rate (LCU per US$ period average) of Sweden?
Offer a terse response. 10.48. In the year 2008, what is the difference between the Official exchange rate (LCU per US$ period average) of Ethiopia and Official exchange rate (LCU per US$ period average) of Sweden?
Give a very brief answer. 3.01. What is the ratio of the Official exchange rate (LCU per US$ period average) in Czech Republic in 2001 to that in 2002?
Ensure brevity in your answer.  1.16. What is the ratio of the Official exchange rate (LCU per US$ period average) in Ethiopia in 2001 to that in 2002?
Your answer should be very brief. 0.99. What is the ratio of the Official exchange rate (LCU per US$ period average) in Sweden in 2001 to that in 2002?
Give a very brief answer. 1.06. What is the ratio of the Official exchange rate (LCU per US$ period average) of Czech Republic in 2001 to that in 2003?
Offer a very short reply. 1.35. What is the ratio of the Official exchange rate (LCU per US$ period average) of Ethiopia in 2001 to that in 2003?
Your response must be concise. 0.98. What is the ratio of the Official exchange rate (LCU per US$ period average) of Sweden in 2001 to that in 2003?
Ensure brevity in your answer.  1.28. What is the ratio of the Official exchange rate (LCU per US$ period average) in Czech Republic in 2001 to that in 2004?
Ensure brevity in your answer.  1.48. What is the ratio of the Official exchange rate (LCU per US$ period average) of Ethiopia in 2001 to that in 2004?
Provide a short and direct response. 0.98. What is the ratio of the Official exchange rate (LCU per US$ period average) in Sweden in 2001 to that in 2004?
Offer a very short reply. 1.41. What is the ratio of the Official exchange rate (LCU per US$ period average) of Czech Republic in 2001 to that in 2005?
Make the answer very short. 1.59. What is the ratio of the Official exchange rate (LCU per US$ period average) of Ethiopia in 2001 to that in 2005?
Your answer should be very brief. 0.98. What is the ratio of the Official exchange rate (LCU per US$ period average) in Sweden in 2001 to that in 2005?
Make the answer very short. 1.38. What is the ratio of the Official exchange rate (LCU per US$ period average) in Czech Republic in 2001 to that in 2006?
Make the answer very short. 1.68. What is the ratio of the Official exchange rate (LCU per US$ period average) of Ethiopia in 2001 to that in 2006?
Make the answer very short. 0.97. What is the ratio of the Official exchange rate (LCU per US$ period average) of Sweden in 2001 to that in 2006?
Offer a very short reply. 1.4. What is the ratio of the Official exchange rate (LCU per US$ period average) in Czech Republic in 2001 to that in 2007?
Your answer should be compact. 1.87. What is the ratio of the Official exchange rate (LCU per US$ period average) in Ethiopia in 2001 to that in 2007?
Your answer should be very brief. 0.94. What is the ratio of the Official exchange rate (LCU per US$ period average) of Sweden in 2001 to that in 2007?
Make the answer very short. 1.53. What is the ratio of the Official exchange rate (LCU per US$ period average) in Czech Republic in 2001 to that in 2008?
Offer a terse response. 2.23. What is the ratio of the Official exchange rate (LCU per US$ period average) in Ethiopia in 2001 to that in 2008?
Your answer should be very brief. 0.88. What is the ratio of the Official exchange rate (LCU per US$ period average) in Sweden in 2001 to that in 2008?
Offer a terse response. 1.57. What is the ratio of the Official exchange rate (LCU per US$ period average) in Czech Republic in 2002 to that in 2003?
Offer a terse response. 1.16. What is the ratio of the Official exchange rate (LCU per US$ period average) of Ethiopia in 2002 to that in 2003?
Provide a short and direct response. 1. What is the ratio of the Official exchange rate (LCU per US$ period average) in Sweden in 2002 to that in 2003?
Provide a short and direct response. 1.2. What is the ratio of the Official exchange rate (LCU per US$ period average) of Czech Republic in 2002 to that in 2004?
Your answer should be very brief. 1.27. What is the ratio of the Official exchange rate (LCU per US$ period average) in Ethiopia in 2002 to that in 2004?
Provide a short and direct response. 0.99. What is the ratio of the Official exchange rate (LCU per US$ period average) in Sweden in 2002 to that in 2004?
Give a very brief answer. 1.32. What is the ratio of the Official exchange rate (LCU per US$ period average) in Czech Republic in 2002 to that in 2005?
Your response must be concise. 1.37. What is the ratio of the Official exchange rate (LCU per US$ period average) of Ethiopia in 2002 to that in 2005?
Your response must be concise. 0.99. What is the ratio of the Official exchange rate (LCU per US$ period average) of Sweden in 2002 to that in 2005?
Keep it short and to the point. 1.3. What is the ratio of the Official exchange rate (LCU per US$ period average) of Czech Republic in 2002 to that in 2006?
Give a very brief answer. 1.45. What is the ratio of the Official exchange rate (LCU per US$ period average) in Ethiopia in 2002 to that in 2006?
Give a very brief answer. 0.98. What is the ratio of the Official exchange rate (LCU per US$ period average) in Sweden in 2002 to that in 2006?
Make the answer very short. 1.32. What is the ratio of the Official exchange rate (LCU per US$ period average) in Czech Republic in 2002 to that in 2007?
Offer a very short reply. 1.61. What is the ratio of the Official exchange rate (LCU per US$ period average) of Ethiopia in 2002 to that in 2007?
Ensure brevity in your answer.  0.96. What is the ratio of the Official exchange rate (LCU per US$ period average) in Sweden in 2002 to that in 2007?
Offer a terse response. 1.44. What is the ratio of the Official exchange rate (LCU per US$ period average) of Czech Republic in 2002 to that in 2008?
Offer a terse response. 1.92. What is the ratio of the Official exchange rate (LCU per US$ period average) in Ethiopia in 2002 to that in 2008?
Ensure brevity in your answer.  0.89. What is the ratio of the Official exchange rate (LCU per US$ period average) in Sweden in 2002 to that in 2008?
Offer a very short reply. 1.48. What is the ratio of the Official exchange rate (LCU per US$ period average) in Czech Republic in 2003 to that in 2004?
Your answer should be very brief. 1.1. What is the ratio of the Official exchange rate (LCU per US$ period average) in Ethiopia in 2003 to that in 2004?
Your response must be concise. 1. What is the ratio of the Official exchange rate (LCU per US$ period average) of Sweden in 2003 to that in 2004?
Give a very brief answer. 1.1. What is the ratio of the Official exchange rate (LCU per US$ period average) of Czech Republic in 2003 to that in 2005?
Your response must be concise. 1.18. What is the ratio of the Official exchange rate (LCU per US$ period average) in Sweden in 2003 to that in 2005?
Make the answer very short. 1.08. What is the ratio of the Official exchange rate (LCU per US$ period average) of Czech Republic in 2003 to that in 2006?
Ensure brevity in your answer.  1.25. What is the ratio of the Official exchange rate (LCU per US$ period average) of Ethiopia in 2003 to that in 2006?
Your response must be concise. 0.99. What is the ratio of the Official exchange rate (LCU per US$ period average) in Sweden in 2003 to that in 2006?
Your response must be concise. 1.1. What is the ratio of the Official exchange rate (LCU per US$ period average) in Czech Republic in 2003 to that in 2007?
Offer a terse response. 1.39. What is the ratio of the Official exchange rate (LCU per US$ period average) in Ethiopia in 2003 to that in 2007?
Your answer should be very brief. 0.96. What is the ratio of the Official exchange rate (LCU per US$ period average) in Sweden in 2003 to that in 2007?
Your answer should be compact. 1.2. What is the ratio of the Official exchange rate (LCU per US$ period average) in Czech Republic in 2003 to that in 2008?
Your answer should be very brief. 1.65. What is the ratio of the Official exchange rate (LCU per US$ period average) of Ethiopia in 2003 to that in 2008?
Your answer should be very brief. 0.9. What is the ratio of the Official exchange rate (LCU per US$ period average) of Sweden in 2003 to that in 2008?
Ensure brevity in your answer.  1.23. What is the ratio of the Official exchange rate (LCU per US$ period average) in Czech Republic in 2004 to that in 2005?
Ensure brevity in your answer.  1.07. What is the ratio of the Official exchange rate (LCU per US$ period average) in Ethiopia in 2004 to that in 2005?
Offer a terse response. 1. What is the ratio of the Official exchange rate (LCU per US$ period average) of Sweden in 2004 to that in 2005?
Give a very brief answer. 0.98. What is the ratio of the Official exchange rate (LCU per US$ period average) in Czech Republic in 2004 to that in 2006?
Provide a short and direct response. 1.14. What is the ratio of the Official exchange rate (LCU per US$ period average) of Ethiopia in 2004 to that in 2006?
Keep it short and to the point. 0.99. What is the ratio of the Official exchange rate (LCU per US$ period average) in Sweden in 2004 to that in 2006?
Make the answer very short. 1. What is the ratio of the Official exchange rate (LCU per US$ period average) in Czech Republic in 2004 to that in 2007?
Your answer should be very brief. 1.27. What is the ratio of the Official exchange rate (LCU per US$ period average) of Ethiopia in 2004 to that in 2007?
Make the answer very short. 0.96. What is the ratio of the Official exchange rate (LCU per US$ period average) in Sweden in 2004 to that in 2007?
Your answer should be compact. 1.09. What is the ratio of the Official exchange rate (LCU per US$ period average) of Czech Republic in 2004 to that in 2008?
Keep it short and to the point. 1.51. What is the ratio of the Official exchange rate (LCU per US$ period average) in Ethiopia in 2004 to that in 2008?
Your answer should be compact. 0.9. What is the ratio of the Official exchange rate (LCU per US$ period average) of Sweden in 2004 to that in 2008?
Offer a terse response. 1.11. What is the ratio of the Official exchange rate (LCU per US$ period average) in Czech Republic in 2005 to that in 2006?
Your answer should be compact. 1.06. What is the ratio of the Official exchange rate (LCU per US$ period average) of Ethiopia in 2005 to that in 2006?
Keep it short and to the point. 1. What is the ratio of the Official exchange rate (LCU per US$ period average) of Sweden in 2005 to that in 2006?
Your response must be concise. 1.01. What is the ratio of the Official exchange rate (LCU per US$ period average) of Czech Republic in 2005 to that in 2007?
Ensure brevity in your answer.  1.18. What is the ratio of the Official exchange rate (LCU per US$ period average) in Ethiopia in 2005 to that in 2007?
Offer a very short reply. 0.97. What is the ratio of the Official exchange rate (LCU per US$ period average) of Sweden in 2005 to that in 2007?
Keep it short and to the point. 1.11. What is the ratio of the Official exchange rate (LCU per US$ period average) in Czech Republic in 2005 to that in 2008?
Provide a succinct answer. 1.4. What is the ratio of the Official exchange rate (LCU per US$ period average) in Ethiopia in 2005 to that in 2008?
Your answer should be compact. 0.9. What is the ratio of the Official exchange rate (LCU per US$ period average) in Sweden in 2005 to that in 2008?
Offer a very short reply. 1.13. What is the ratio of the Official exchange rate (LCU per US$ period average) of Czech Republic in 2006 to that in 2007?
Your response must be concise. 1.11. What is the ratio of the Official exchange rate (LCU per US$ period average) of Ethiopia in 2006 to that in 2007?
Make the answer very short. 0.97. What is the ratio of the Official exchange rate (LCU per US$ period average) in Sweden in 2006 to that in 2007?
Make the answer very short. 1.09. What is the ratio of the Official exchange rate (LCU per US$ period average) of Czech Republic in 2006 to that in 2008?
Offer a terse response. 1.32. What is the ratio of the Official exchange rate (LCU per US$ period average) in Ethiopia in 2006 to that in 2008?
Offer a very short reply. 0.91. What is the ratio of the Official exchange rate (LCU per US$ period average) of Sweden in 2006 to that in 2008?
Make the answer very short. 1.12. What is the ratio of the Official exchange rate (LCU per US$ period average) in Czech Republic in 2007 to that in 2008?
Provide a short and direct response. 1.19. What is the ratio of the Official exchange rate (LCU per US$ period average) in Ethiopia in 2007 to that in 2008?
Ensure brevity in your answer.  0.93. What is the ratio of the Official exchange rate (LCU per US$ period average) in Sweden in 2007 to that in 2008?
Provide a succinct answer. 1.03. What is the difference between the highest and the second highest Official exchange rate (LCU per US$ period average) of Czech Republic?
Provide a succinct answer. 5.3. What is the difference between the highest and the second highest Official exchange rate (LCU per US$ period average) in Ethiopia?
Your response must be concise. 0.63. What is the difference between the highest and the second highest Official exchange rate (LCU per US$ period average) in Sweden?
Ensure brevity in your answer.  0.59. What is the difference between the highest and the lowest Official exchange rate (LCU per US$ period average) of Czech Republic?
Offer a very short reply. 20.96. What is the difference between the highest and the lowest Official exchange rate (LCU per US$ period average) in Ethiopia?
Ensure brevity in your answer.  1.14. What is the difference between the highest and the lowest Official exchange rate (LCU per US$ period average) of Sweden?
Offer a very short reply. 3.74. 